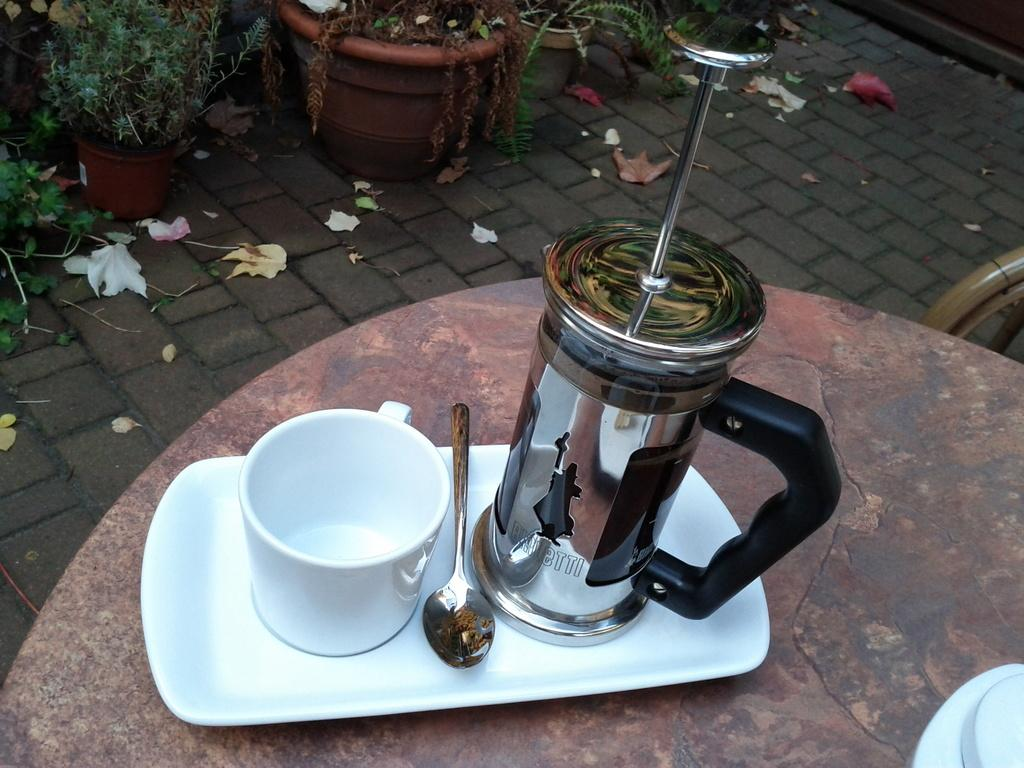What piece of furniture is present in the image? There is a table in the image. What is placed on the table? There is a tray on the table. What items are on the tray? There is a cup, a spoon, and a jar on the tray. What can be seen in the background of the image? There are pots with plants on the floor in the background. What type of collar can be seen on the town in the image? There is no town or collar present in the image. 